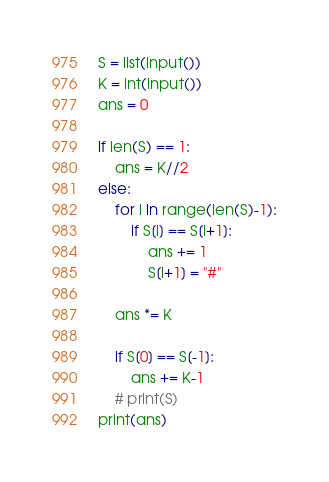<code> <loc_0><loc_0><loc_500><loc_500><_Python_>S = list(input())
K = int(input())
ans = 0

if len(S) == 1:
    ans = K//2
else:
    for i in range(len(S)-1):
        if S[i] == S[i+1]:
            ans += 1
            S[i+1] = "#"

    ans *= K

    if S[0] == S[-1]:
        ans += K-1
    # print(S)
print(ans)</code> 